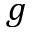<formula> <loc_0><loc_0><loc_500><loc_500>g</formula> 